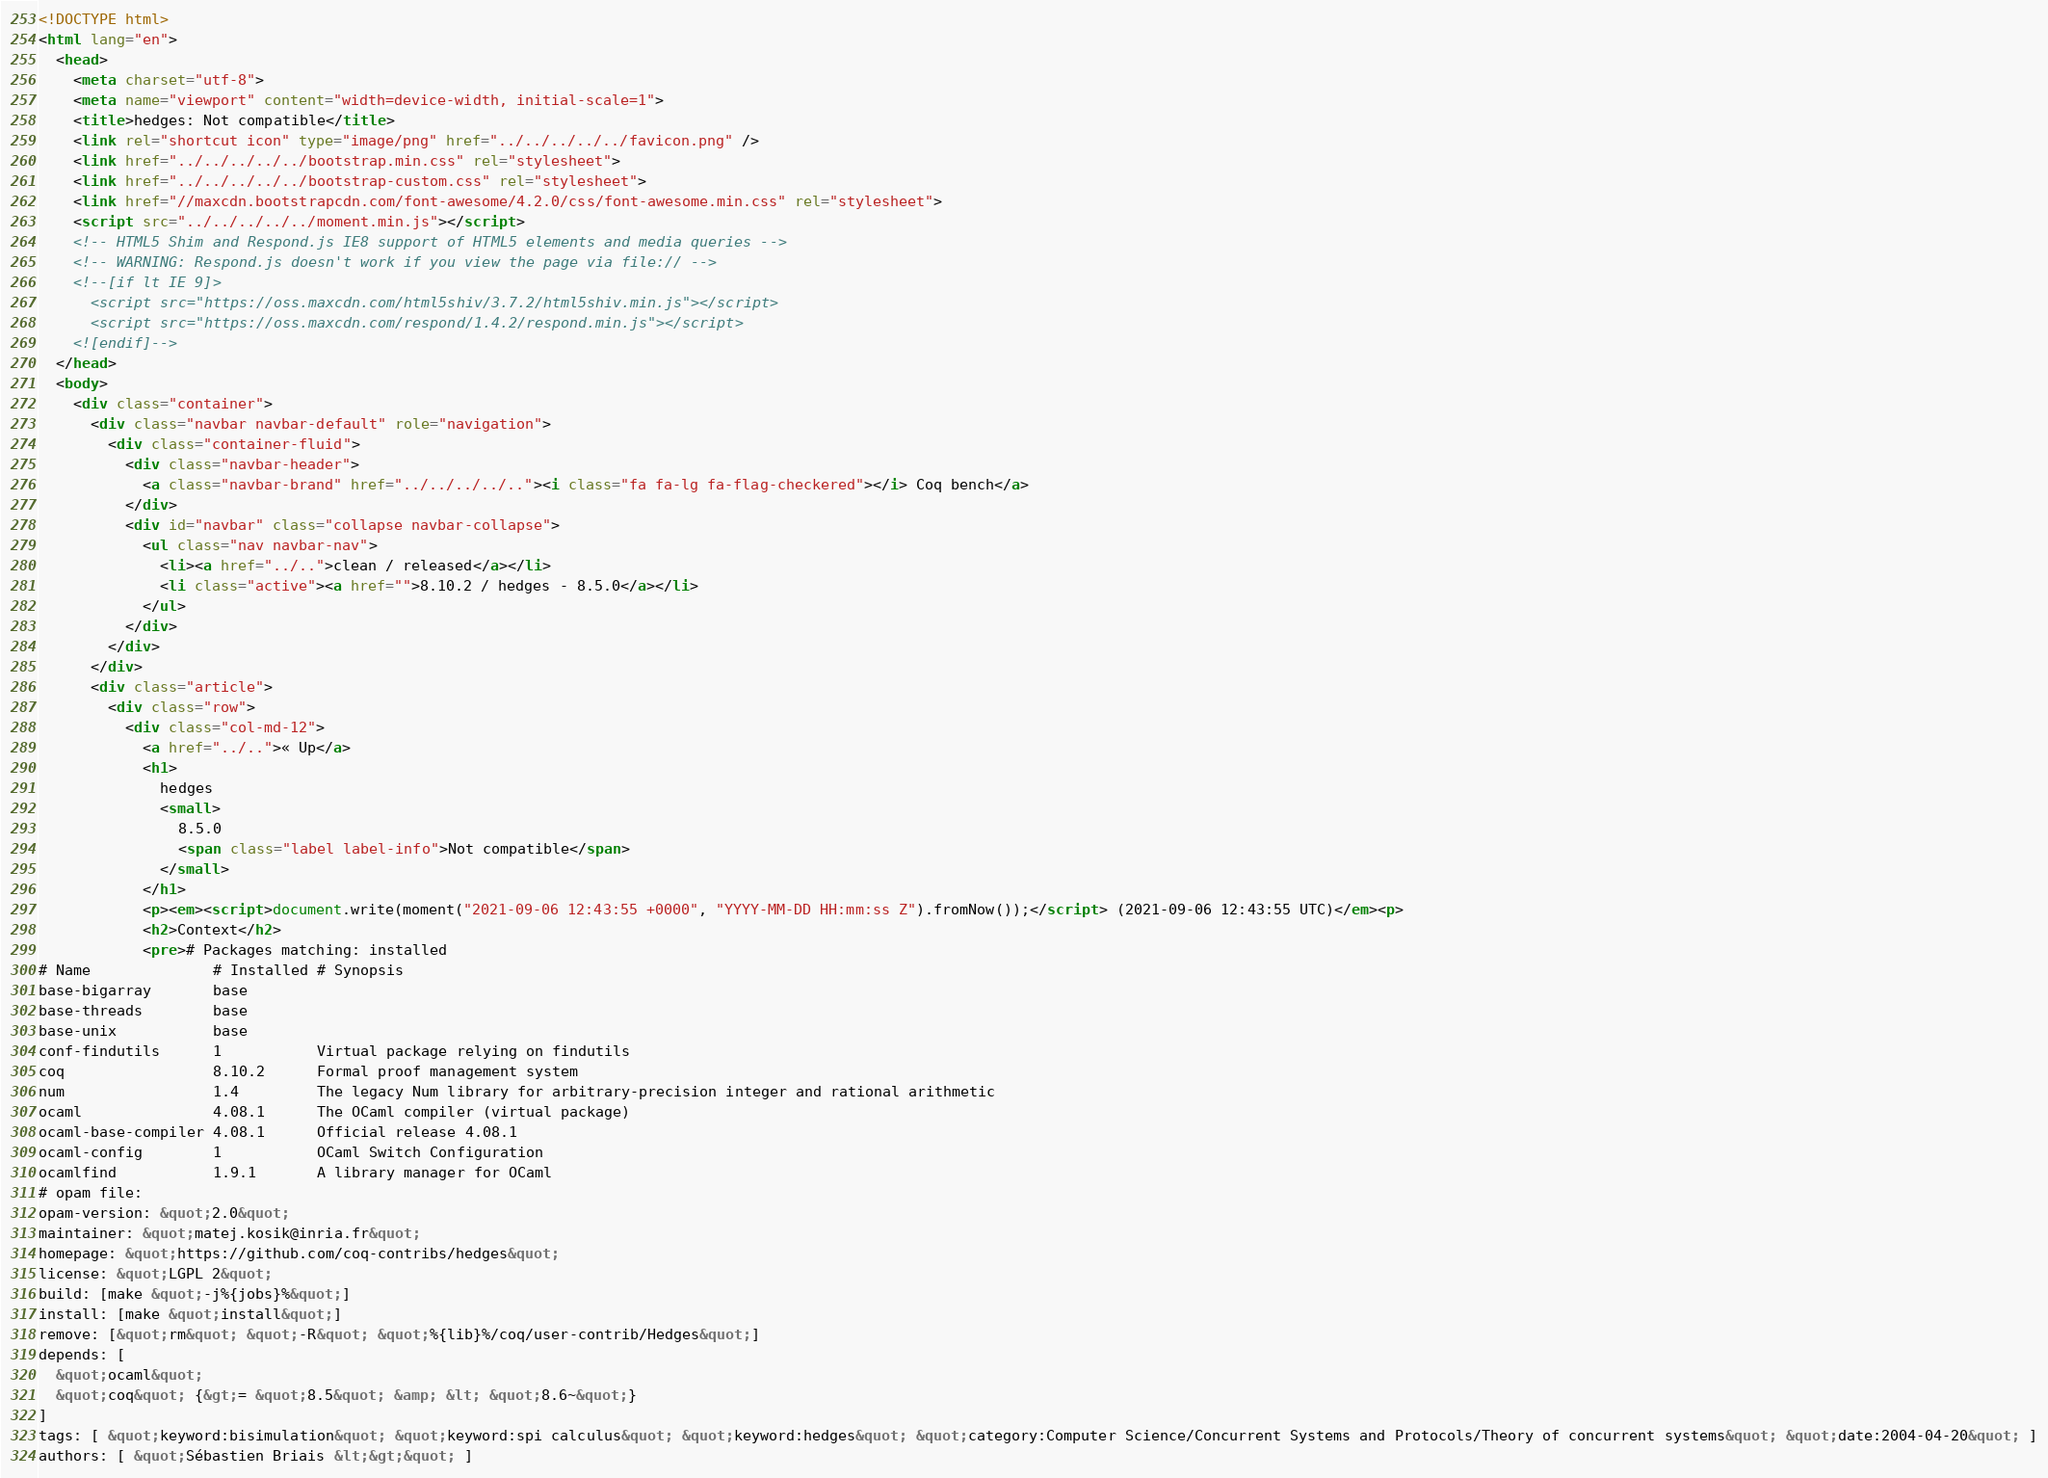Convert code to text. <code><loc_0><loc_0><loc_500><loc_500><_HTML_><!DOCTYPE html>
<html lang="en">
  <head>
    <meta charset="utf-8">
    <meta name="viewport" content="width=device-width, initial-scale=1">
    <title>hedges: Not compatible</title>
    <link rel="shortcut icon" type="image/png" href="../../../../../favicon.png" />
    <link href="../../../../../bootstrap.min.css" rel="stylesheet">
    <link href="../../../../../bootstrap-custom.css" rel="stylesheet">
    <link href="//maxcdn.bootstrapcdn.com/font-awesome/4.2.0/css/font-awesome.min.css" rel="stylesheet">
    <script src="../../../../../moment.min.js"></script>
    <!-- HTML5 Shim and Respond.js IE8 support of HTML5 elements and media queries -->
    <!-- WARNING: Respond.js doesn't work if you view the page via file:// -->
    <!--[if lt IE 9]>
      <script src="https://oss.maxcdn.com/html5shiv/3.7.2/html5shiv.min.js"></script>
      <script src="https://oss.maxcdn.com/respond/1.4.2/respond.min.js"></script>
    <![endif]-->
  </head>
  <body>
    <div class="container">
      <div class="navbar navbar-default" role="navigation">
        <div class="container-fluid">
          <div class="navbar-header">
            <a class="navbar-brand" href="../../../../.."><i class="fa fa-lg fa-flag-checkered"></i> Coq bench</a>
          </div>
          <div id="navbar" class="collapse navbar-collapse">
            <ul class="nav navbar-nav">
              <li><a href="../..">clean / released</a></li>
              <li class="active"><a href="">8.10.2 / hedges - 8.5.0</a></li>
            </ul>
          </div>
        </div>
      </div>
      <div class="article">
        <div class="row">
          <div class="col-md-12">
            <a href="../..">« Up</a>
            <h1>
              hedges
              <small>
                8.5.0
                <span class="label label-info">Not compatible</span>
              </small>
            </h1>
            <p><em><script>document.write(moment("2021-09-06 12:43:55 +0000", "YYYY-MM-DD HH:mm:ss Z").fromNow());</script> (2021-09-06 12:43:55 UTC)</em><p>
            <h2>Context</h2>
            <pre># Packages matching: installed
# Name              # Installed # Synopsis
base-bigarray       base
base-threads        base
base-unix           base
conf-findutils      1           Virtual package relying on findutils
coq                 8.10.2      Formal proof management system
num                 1.4         The legacy Num library for arbitrary-precision integer and rational arithmetic
ocaml               4.08.1      The OCaml compiler (virtual package)
ocaml-base-compiler 4.08.1      Official release 4.08.1
ocaml-config        1           OCaml Switch Configuration
ocamlfind           1.9.1       A library manager for OCaml
# opam file:
opam-version: &quot;2.0&quot;
maintainer: &quot;matej.kosik@inria.fr&quot;
homepage: &quot;https://github.com/coq-contribs/hedges&quot;
license: &quot;LGPL 2&quot;
build: [make &quot;-j%{jobs}%&quot;]
install: [make &quot;install&quot;]
remove: [&quot;rm&quot; &quot;-R&quot; &quot;%{lib}%/coq/user-contrib/Hedges&quot;]
depends: [
  &quot;ocaml&quot;
  &quot;coq&quot; {&gt;= &quot;8.5&quot; &amp; &lt; &quot;8.6~&quot;}
]
tags: [ &quot;keyword:bisimulation&quot; &quot;keyword:spi calculus&quot; &quot;keyword:hedges&quot; &quot;category:Computer Science/Concurrent Systems and Protocols/Theory of concurrent systems&quot; &quot;date:2004-04-20&quot; ]
authors: [ &quot;Sébastien Briais &lt;&gt;&quot; ]</code> 